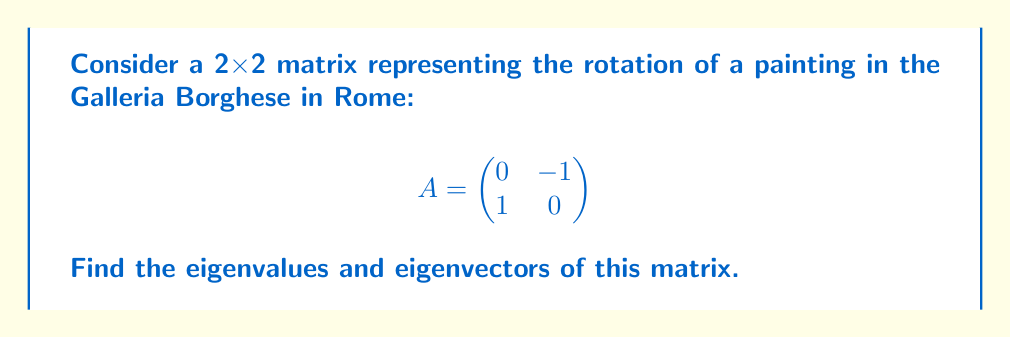Can you solve this math problem? To find the eigenvalues and eigenvectors, we follow these steps:

1. Find the characteristic equation:
   $det(A - \lambda I) = 0$
   
   $$\begin{vmatrix}
   -\lambda & -1 \\
   1 & -\lambda
   \end{vmatrix} = 0$$
   
   $\lambda^2 + 1 = 0$

2. Solve for $\lambda$:
   $\lambda = \pm i$

3. Find eigenvectors for each eigenvalue:

   For $\lambda = i$:
   $(A - iI)v = 0$
   
   $$\begin{pmatrix}
   -i & -1 \\
   1 & -i
   \end{pmatrix}\begin{pmatrix}
   v_1 \\
   v_2
   \end{pmatrix} = \begin{pmatrix}
   0 \\
   0
   \end{pmatrix}$$
   
   This gives us: $-iv_1 - v_2 = 0$
   
   Choose $v_1 = 1$, then $v_2 = -i$
   
   Eigenvector for $\lambda = i$ is $v_1 = \begin{pmatrix} 1 \\ -i \end{pmatrix}$

   For $\lambda = -i$:
   $(A + iI)v = 0$
   
   $$\begin{pmatrix}
   i & -1 \\
   1 & i
   \end{pmatrix}\begin{pmatrix}
   v_1 \\
   v_2
   \end{pmatrix} = \begin{pmatrix}
   0 \\
   0
   \end{pmatrix}$$
   
   This gives us: $iv_1 - v_2 = 0$
   
   Choose $v_1 = 1$, then $v_2 = i$
   
   Eigenvector for $\lambda = -i$ is $v_2 = \begin{pmatrix} 1 \\ i \end{pmatrix}$
Answer: Eigenvalues: $\lambda_1 = i$, $\lambda_2 = -i$
Eigenvectors: $v_1 = \begin{pmatrix} 1 \\ -i \end{pmatrix}$, $v_2 = \begin{pmatrix} 1 \\ i \end{pmatrix}$ 